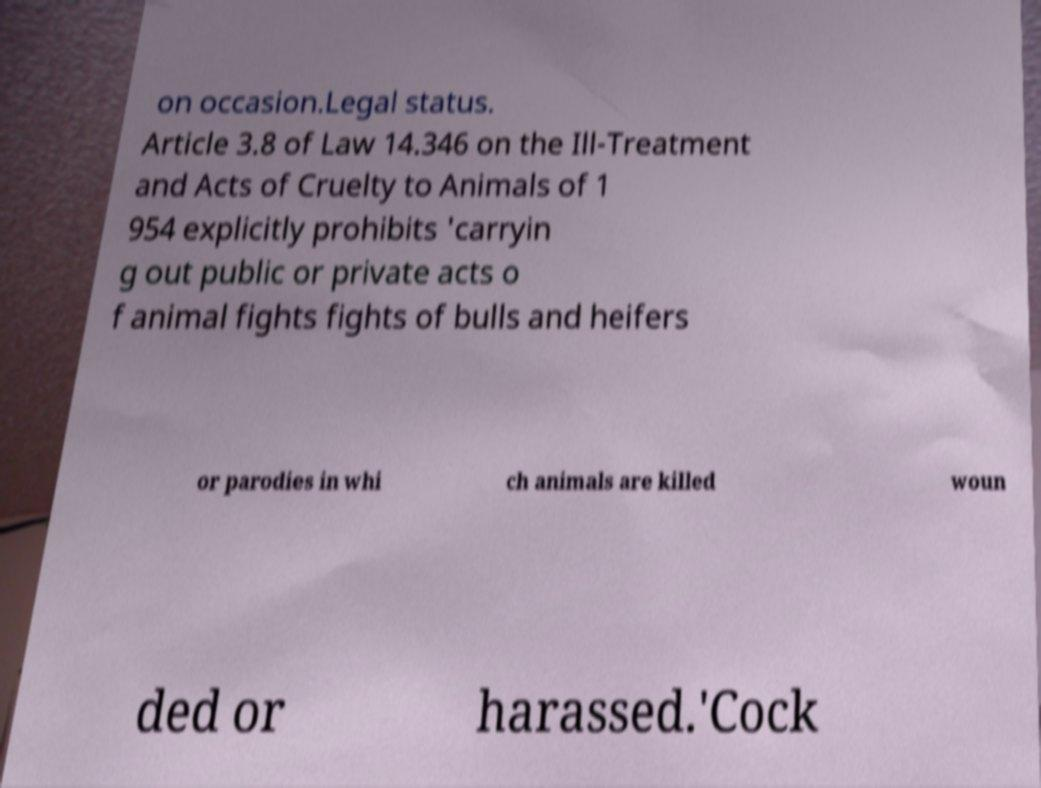Please read and relay the text visible in this image. What does it say? on occasion.Legal status. Article 3.8 of Law 14.346 on the Ill-Treatment and Acts of Cruelty to Animals of 1 954 explicitly prohibits 'carryin g out public or private acts o f animal fights fights of bulls and heifers or parodies in whi ch animals are killed woun ded or harassed.'Cock 